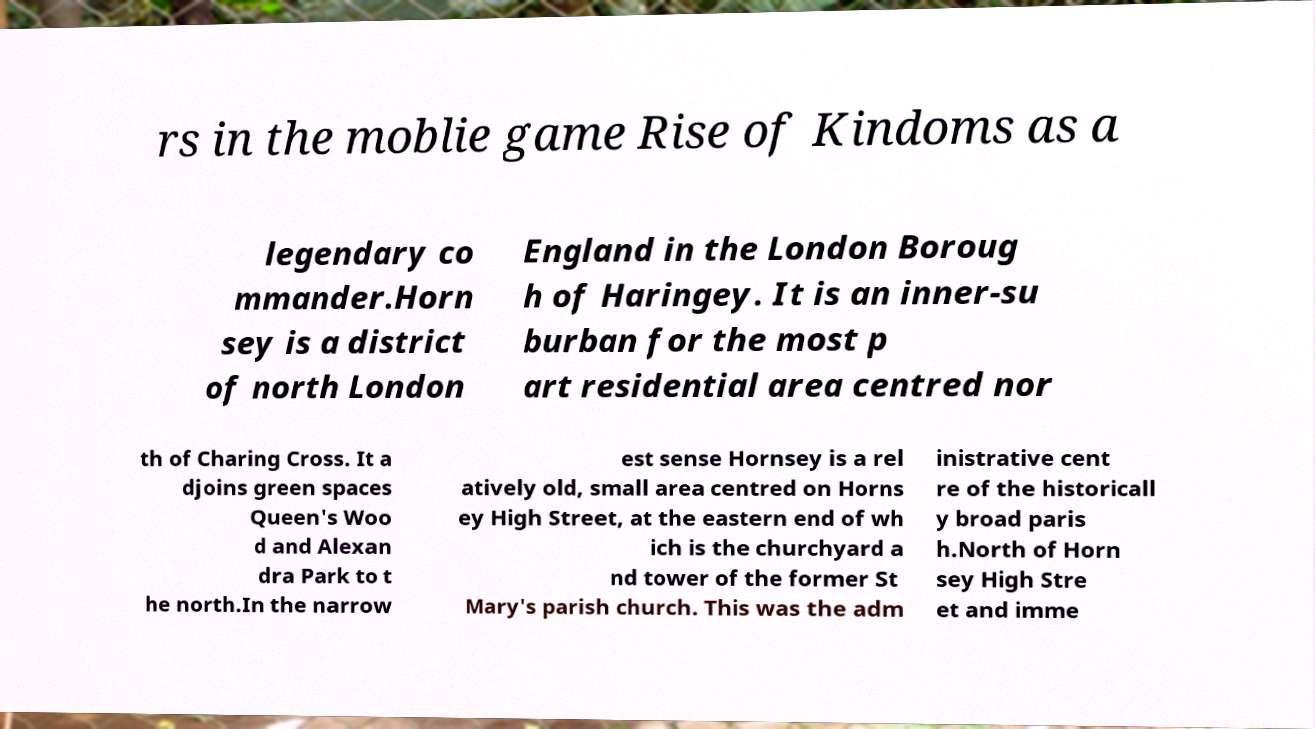I need the written content from this picture converted into text. Can you do that? rs in the moblie game Rise of Kindoms as a legendary co mmander.Horn sey is a district of north London England in the London Boroug h of Haringey. It is an inner-su burban for the most p art residential area centred nor th of Charing Cross. It a djoins green spaces Queen's Woo d and Alexan dra Park to t he north.In the narrow est sense Hornsey is a rel atively old, small area centred on Horns ey High Street, at the eastern end of wh ich is the churchyard a nd tower of the former St Mary's parish church. This was the adm inistrative cent re of the historicall y broad paris h.North of Horn sey High Stre et and imme 